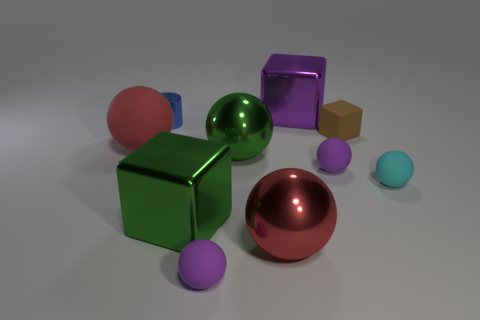There is another large red object that is the same shape as the red shiny thing; what material is it?
Offer a very short reply. Rubber. What color is the tiny matte block?
Provide a short and direct response. Brown. What size is the purple cube that is made of the same material as the large green sphere?
Provide a short and direct response. Large. What number of small brown rubber things have the same shape as the tiny metal object?
Your answer should be compact. 0. Are there any other things that have the same size as the brown thing?
Provide a succinct answer. Yes. What size is the purple matte sphere to the right of the purple thing behind the small brown matte thing?
Provide a succinct answer. Small. There is a blue cylinder that is the same size as the rubber block; what is its material?
Provide a succinct answer. Metal. Is there a gray cube that has the same material as the cyan ball?
Provide a short and direct response. No. There is a small object in front of the big red sphere right of the thing left of the small blue metal object; what is its color?
Offer a terse response. Purple. Is the color of the small ball that is on the right side of the tiny brown rubber cube the same as the large shiny block in front of the brown matte thing?
Offer a terse response. No. 